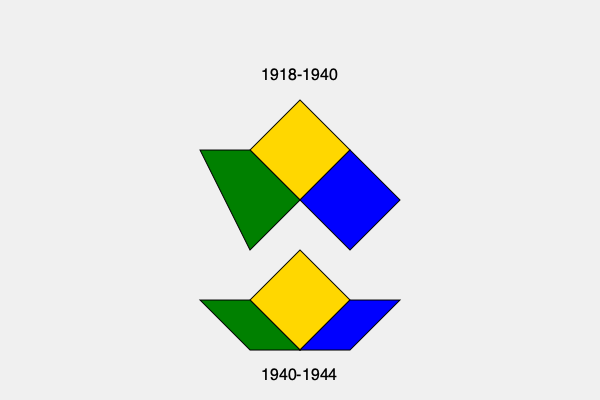Based on the map showing Romania's territorial changes in the 20th century, which region was lost between 1940 and 1944 that was previously part of Greater Romania (1918-1940)? To answer this question, we need to analyze the territorial changes of Romania as shown in the map:

1. The top diamond shape represents Romania's territory from 1918-1940, known as "Greater Romania."
2. This larger territory includes three distinct regions:
   - Yellow (center): Core Romanian territory
   - Green (left): Western region
   - Blue (right): Eastern region
3. The bottom shape represents Romania's territory from 1940-1944.
4. Comparing the two periods, we can see that:
   - The yellow center region remains constant
   - The green western region remains part of Romania
   - The blue eastern region is missing from the 1940-1944 map
5. Therefore, the region lost between 1940 and 1944 is the eastern region, which historically corresponds to Bessarabia and Northern Bukovina.

This loss occurred as a result of the Molotov-Ribbentrop Pact between Nazi Germany and the Soviet Union, leading to the Soviet annexation of these territories in 1940.
Answer: Bessarabia and Northern Bukovina 